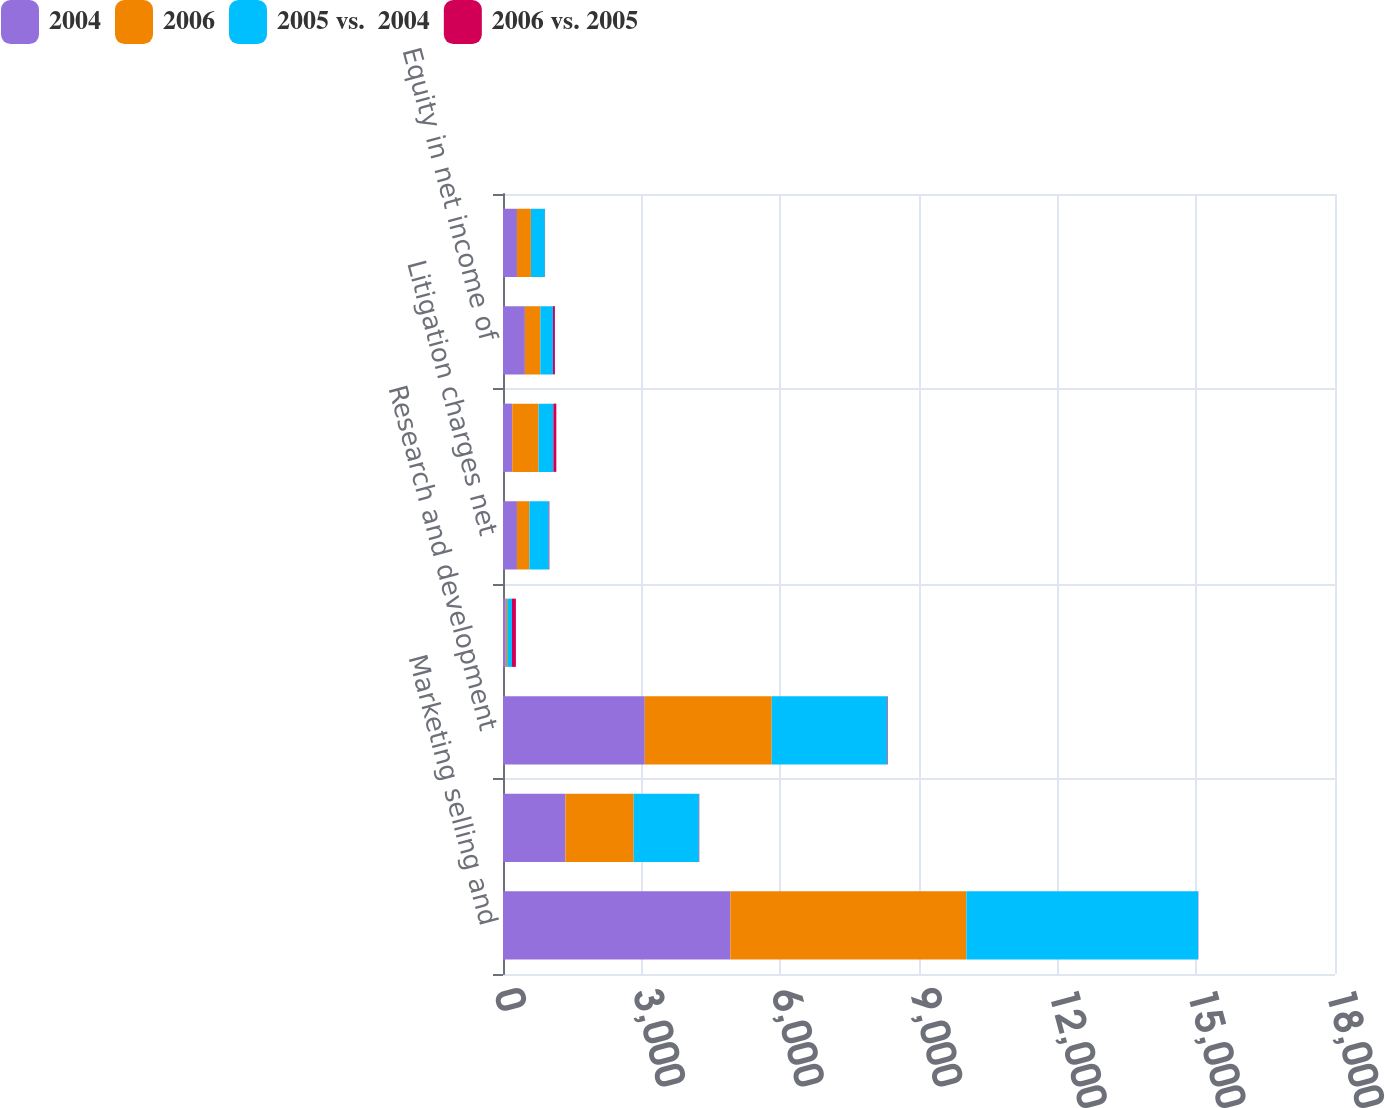Convert chart to OTSL. <chart><loc_0><loc_0><loc_500><loc_500><stacked_bar_chart><ecel><fcel>Marketing selling and<fcel>Advertising and product<fcel>Research and development<fcel>Provision for restructuring<fcel>Litigation charges net<fcel>Gain on sale of businesses<fcel>Equity in net income of<fcel>Total Expenses net<nl><fcel>2004<fcel>4919<fcel>1351<fcel>3067<fcel>59<fcel>302<fcel>200<fcel>474<fcel>302<nl><fcel>2006<fcel>5106<fcel>1476<fcel>2746<fcel>32<fcel>269<fcel>569<fcel>334<fcel>302<nl><fcel>2005 vs.  2004<fcel>5016<fcel>1411<fcel>2500<fcel>104<fcel>420<fcel>320<fcel>273<fcel>302<nl><fcel>2006 vs. 2005<fcel>4<fcel>8<fcel>12<fcel>84<fcel>12<fcel>65<fcel>42<fcel>4<nl></chart> 